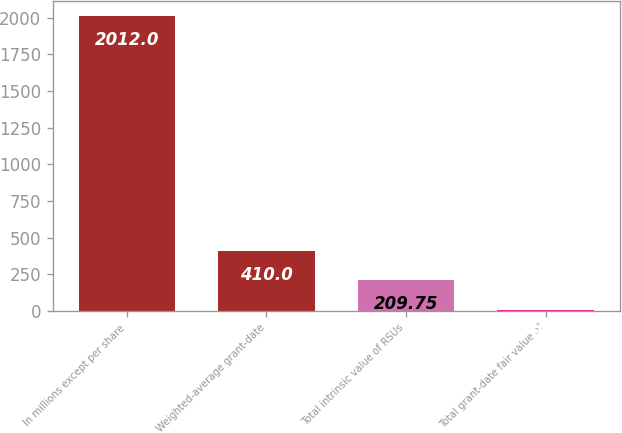Convert chart to OTSL. <chart><loc_0><loc_0><loc_500><loc_500><bar_chart><fcel>In millions except per share<fcel>Weighted-average grant-date<fcel>Total intrinsic value of RSUs<fcel>Total grant-date fair value of<nl><fcel>2012<fcel>410<fcel>209.75<fcel>9.5<nl></chart> 